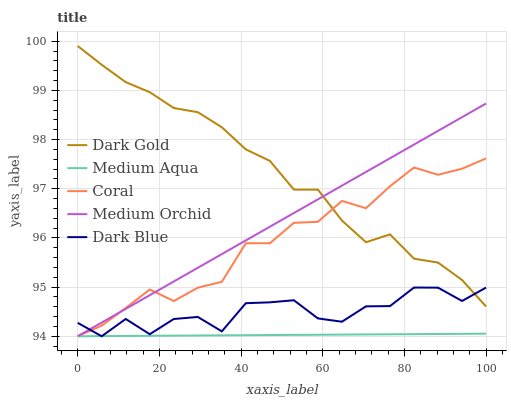Does Coral have the minimum area under the curve?
Answer yes or no. No. Does Coral have the maximum area under the curve?
Answer yes or no. No. Is Coral the smoothest?
Answer yes or no. No. Is Coral the roughest?
Answer yes or no. No. Does Dark Gold have the lowest value?
Answer yes or no. No. Does Coral have the highest value?
Answer yes or no. No. Is Medium Aqua less than Dark Gold?
Answer yes or no. Yes. Is Dark Gold greater than Medium Aqua?
Answer yes or no. Yes. Does Medium Aqua intersect Dark Gold?
Answer yes or no. No. 